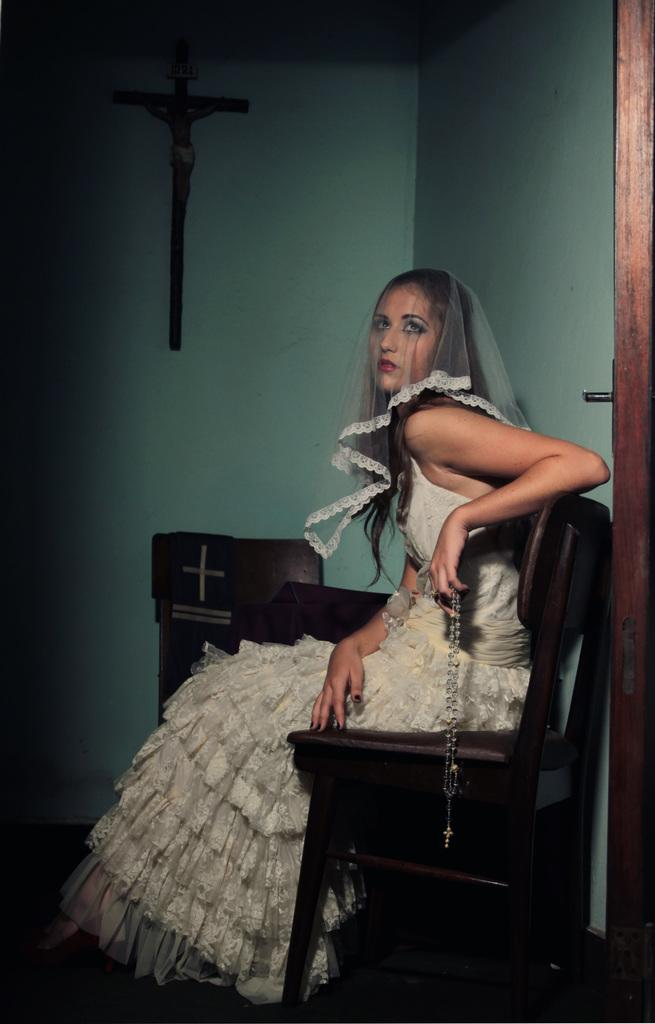Who is present in the image? There is a lady in the image. What is the lady doing in the image? The lady is sitting and holding an object. How many chairs are visible in the image? There are chairs in the image. What can be seen on the ground in the image? The ground is visible in the image. What is on the wall in the image? There is a wall with objects in the image. What material is present on the right side of the image? There is wood on the right side of the image. What color is the dad's eye in the image? There is no dad or eye present in the image. 